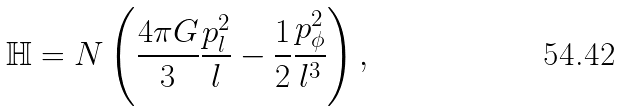<formula> <loc_0><loc_0><loc_500><loc_500>\mathbb { H } = N \left ( \frac { 4 \pi G } { 3 } \frac { p _ { l } ^ { 2 } } { l } - \frac { 1 } { 2 } \frac { p _ { \phi } ^ { 2 } } { l ^ { 3 } } \right ) ,</formula> 